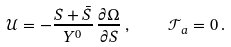<formula> <loc_0><loc_0><loc_500><loc_500>\mathcal { U } = - \frac { S + \bar { S } } { Y ^ { 0 } } \, \frac { \partial \Omega } { \partial S } \, , \quad \mathcal { T } _ { a } = 0 \, .</formula> 